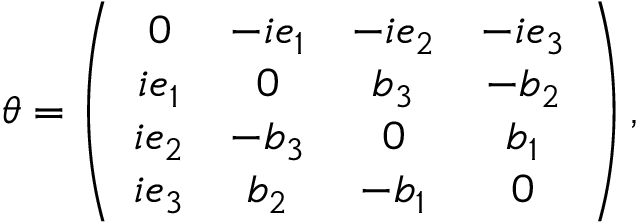<formula> <loc_0><loc_0><loc_500><loc_500>\theta = \left ( \begin{array} { c c c c } { 0 } & { { - i e _ { 1 } } } & { { - i e _ { 2 } } } & { { - i e _ { 3 } } } \\ { { i e _ { 1 } } } & { 0 } & { { b _ { 3 } } } & { { - b _ { 2 } } } \\ { { i e _ { 2 } } } & { { - b _ { 3 } } } & { 0 } & { { b _ { 1 } } } \\ { { i e _ { 3 } } } & { { b _ { 2 } } } & { { - b _ { 1 } } } & { 0 } \end{array} \right ) ,</formula> 